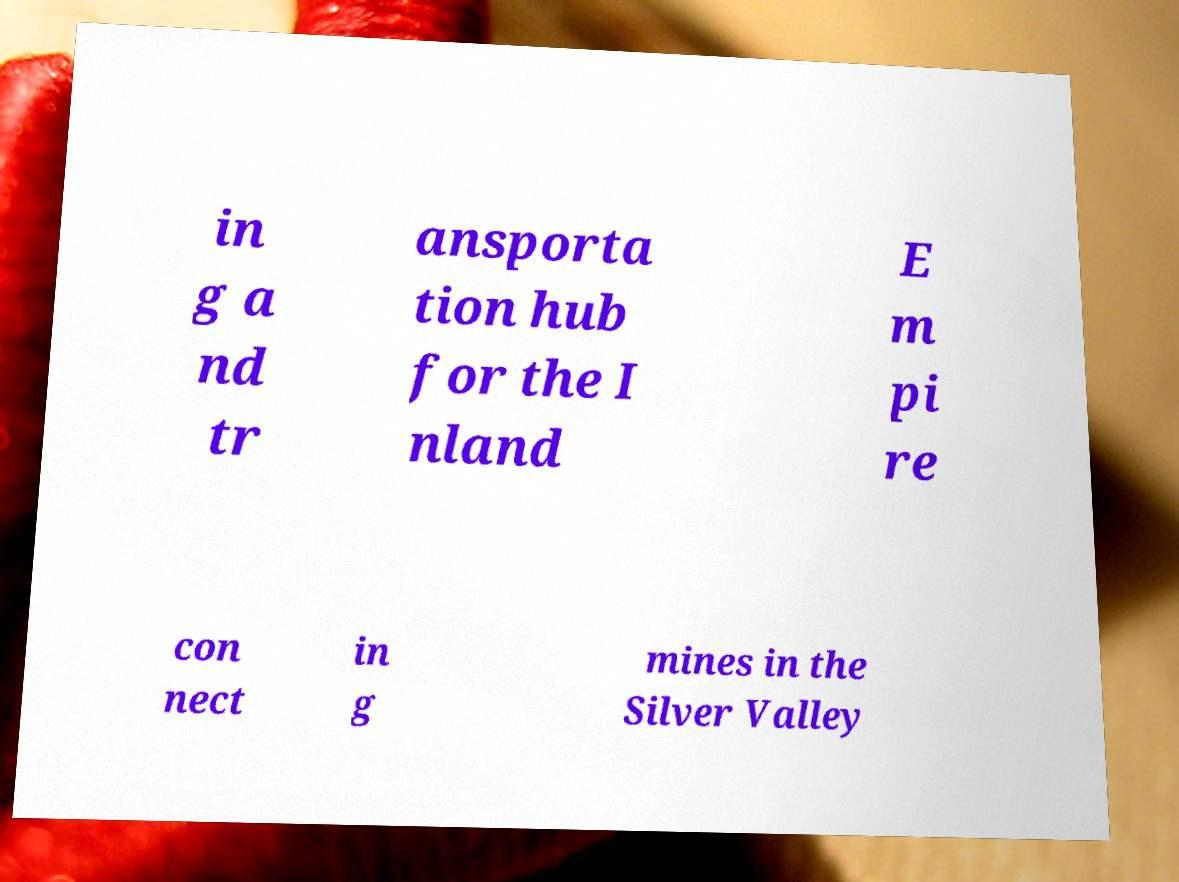What messages or text are displayed in this image? I need them in a readable, typed format. in g a nd tr ansporta tion hub for the I nland E m pi re con nect in g mines in the Silver Valley 